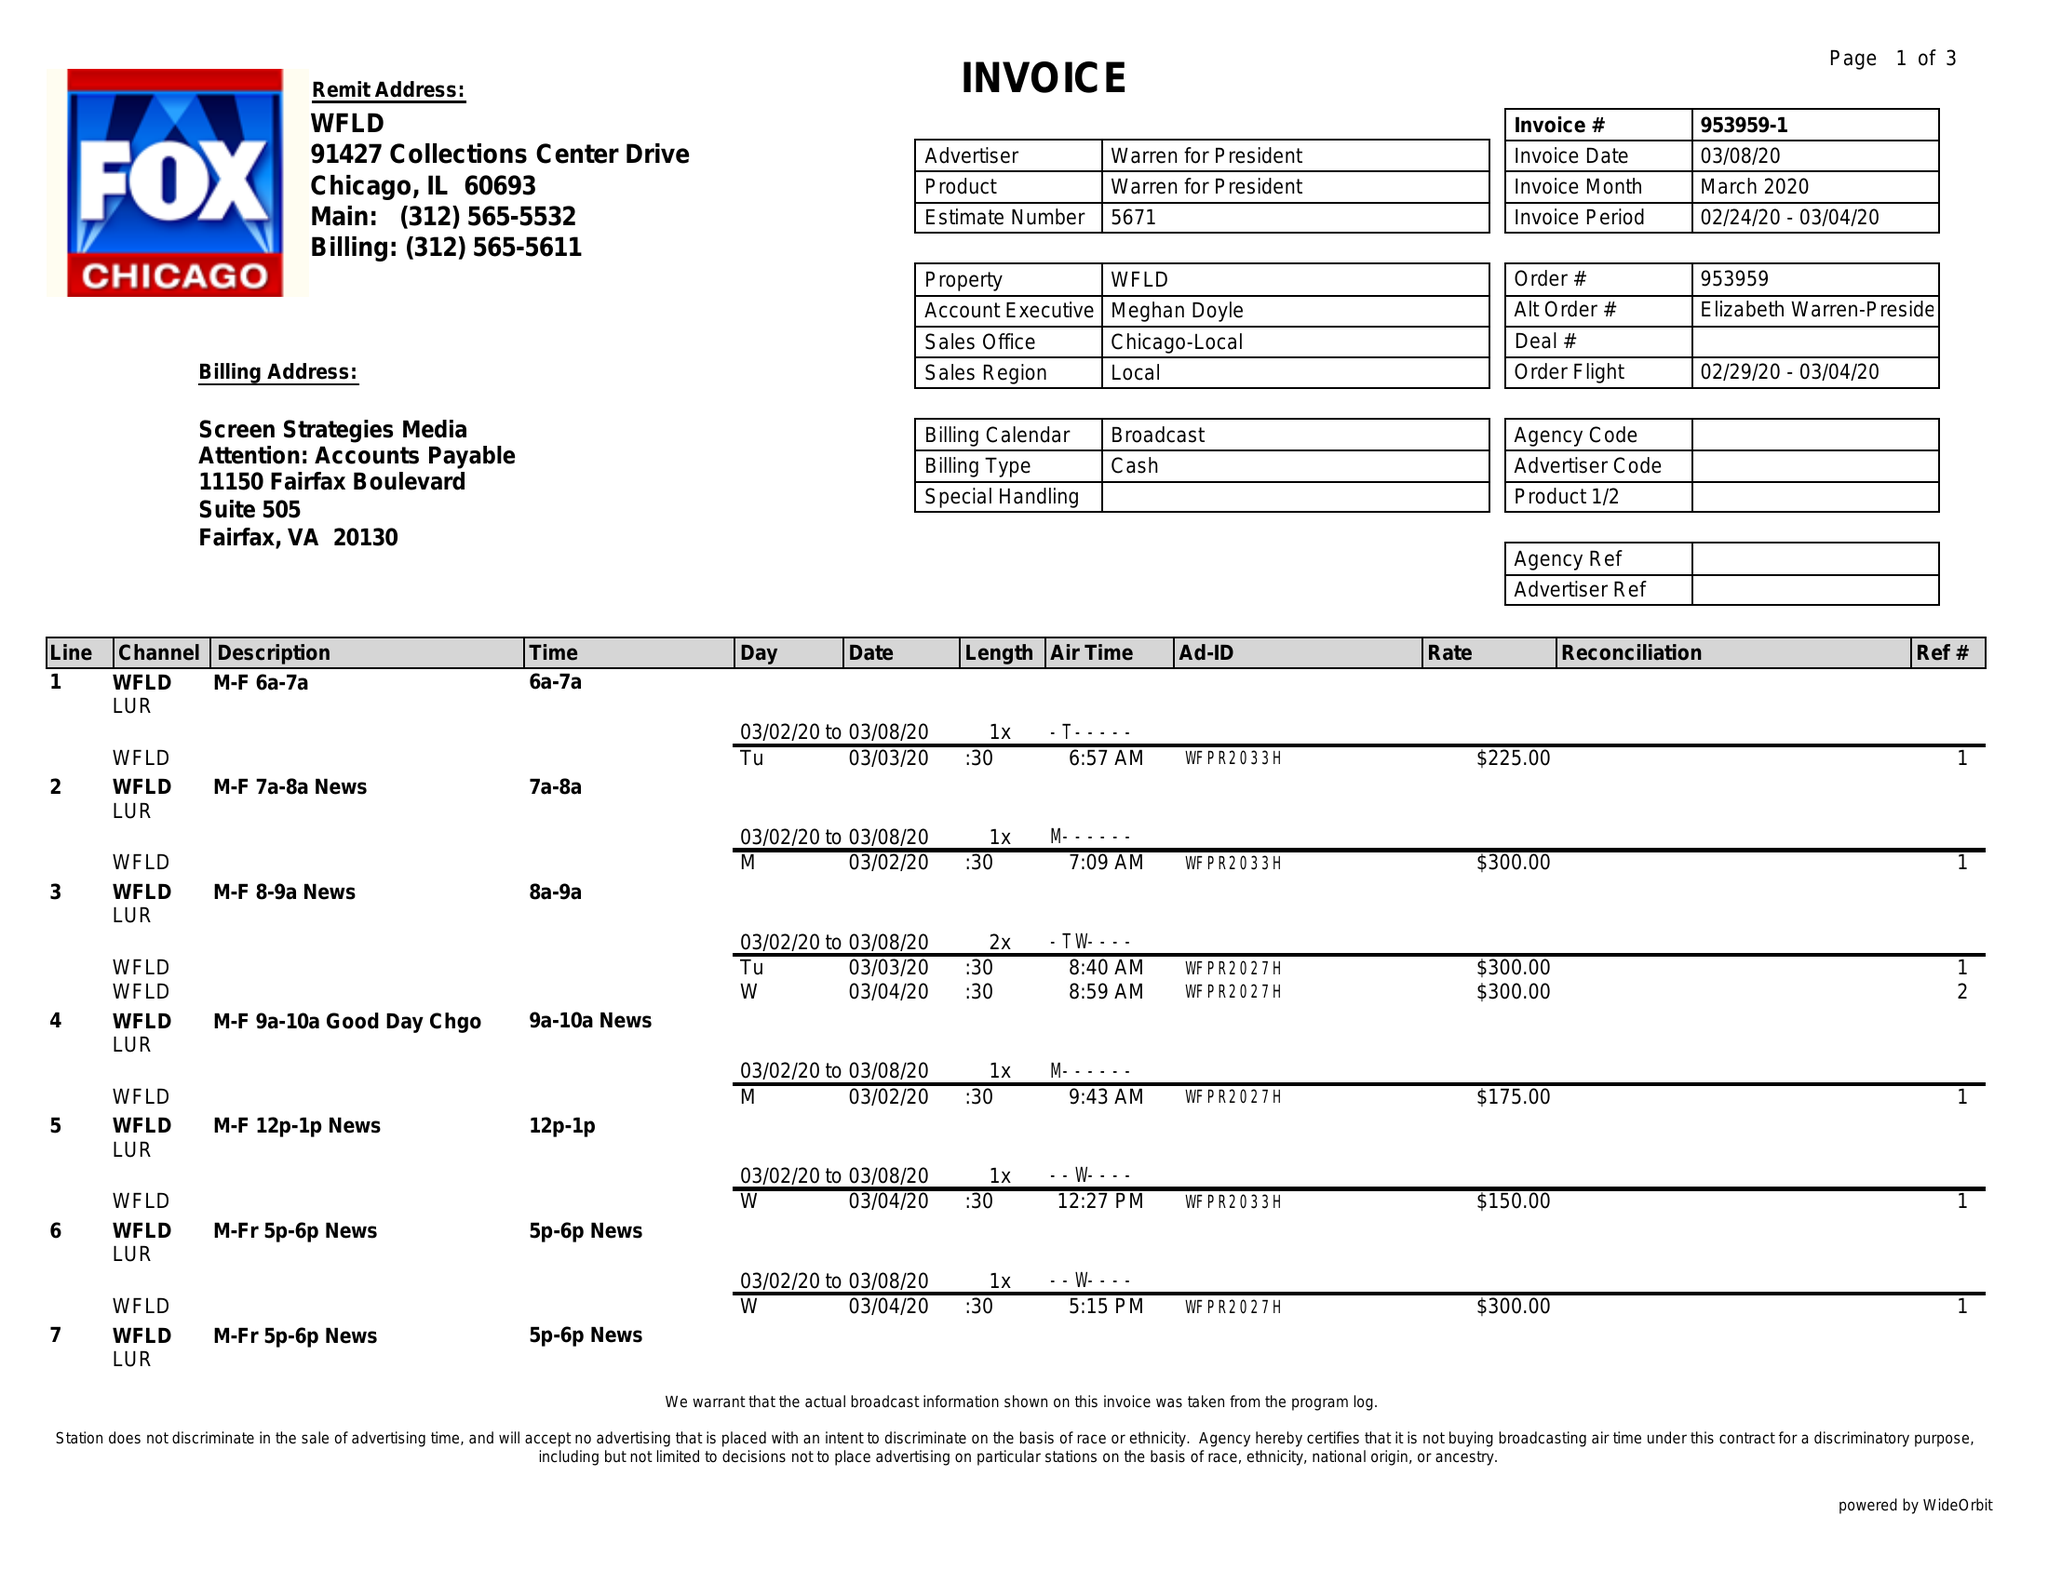What is the value for the advertiser?
Answer the question using a single word or phrase. WARREN FOR PRESIDENT 